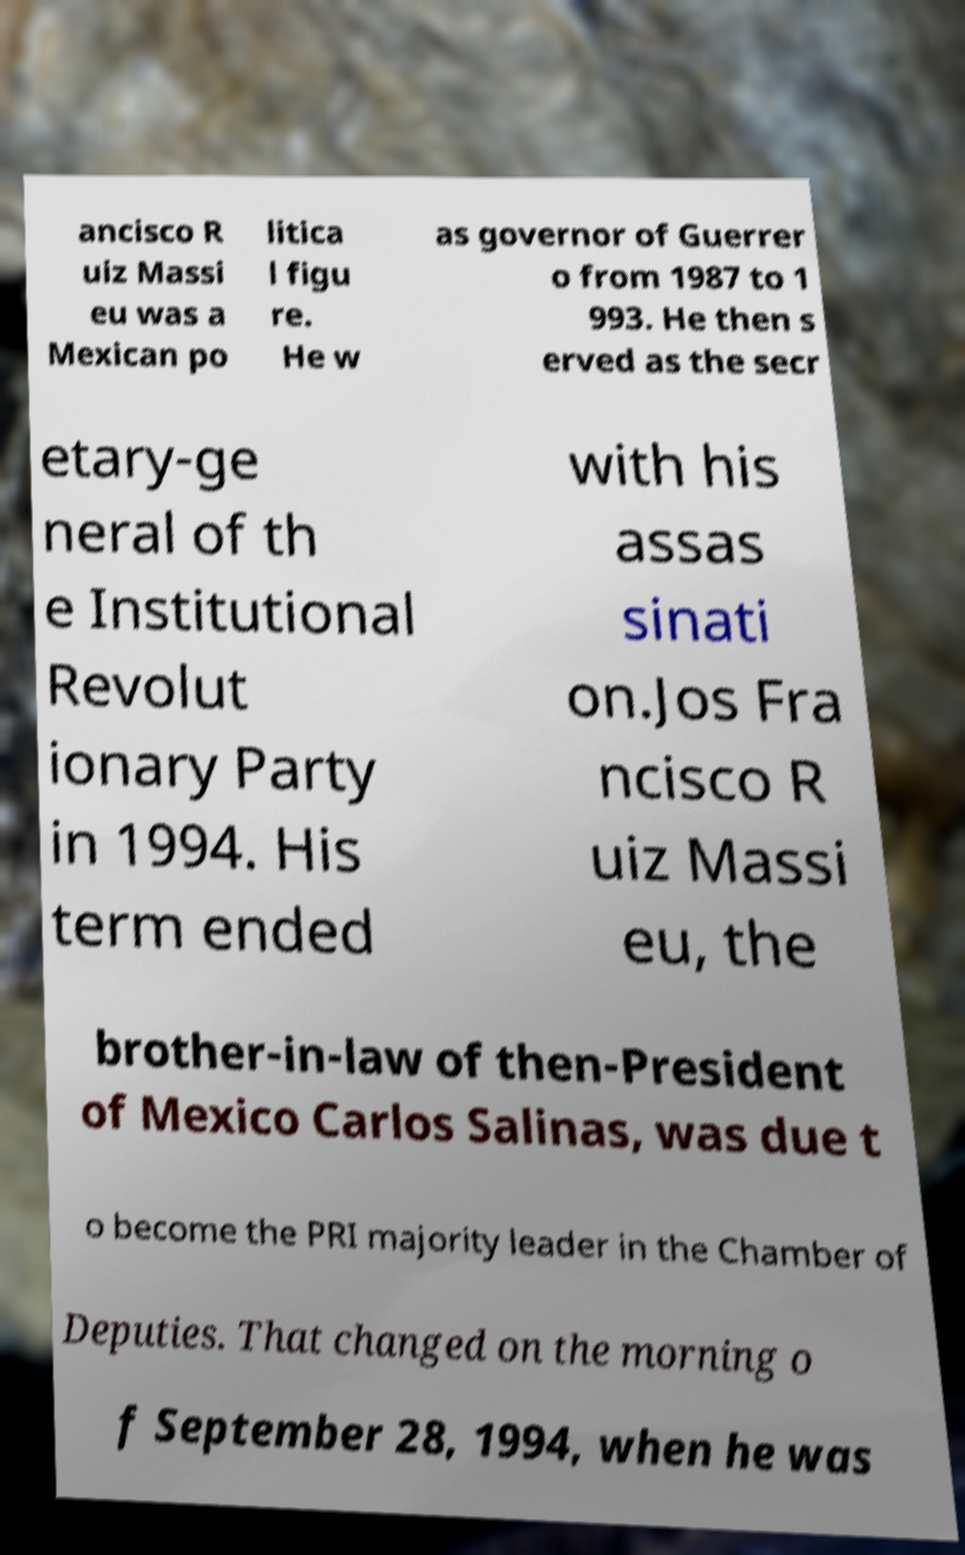Can you read and provide the text displayed in the image?This photo seems to have some interesting text. Can you extract and type it out for me? ancisco R uiz Massi eu was a Mexican po litica l figu re. He w as governor of Guerrer o from 1987 to 1 993. He then s erved as the secr etary-ge neral of th e Institutional Revolut ionary Party in 1994. His term ended with his assas sinati on.Jos Fra ncisco R uiz Massi eu, the brother-in-law of then-President of Mexico Carlos Salinas, was due t o become the PRI majority leader in the Chamber of Deputies. That changed on the morning o f September 28, 1994, when he was 